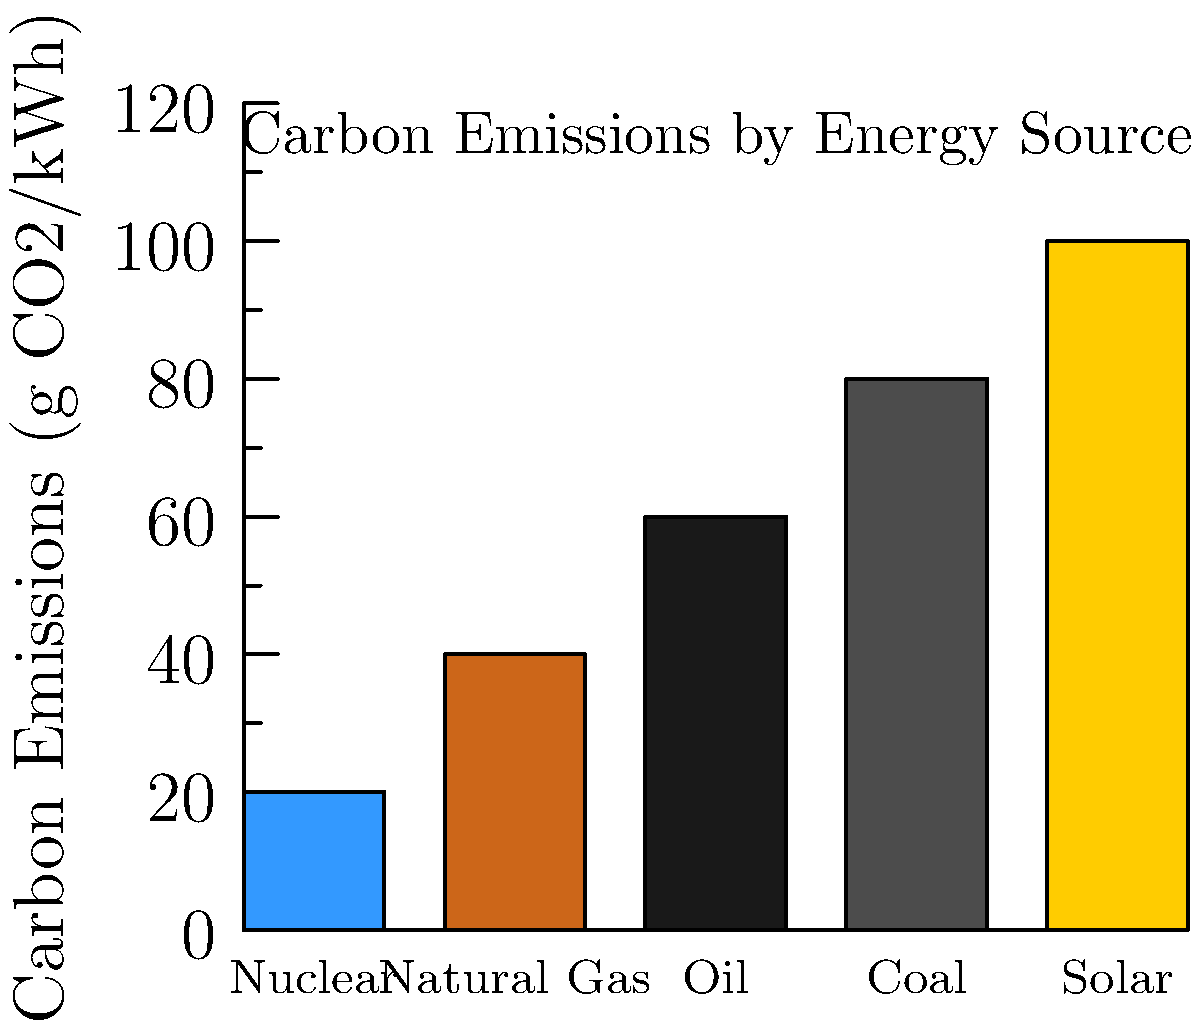Based on the bar chart showing carbon emissions for different energy sources, which fossil fuel source has the lowest carbon emissions per kWh? How would you use this information to support the continued use of fossil fuels in energy production? To answer this question, let's analyze the bar chart step-by-step:

1. The chart shows carbon emissions in grams of CO2 per kWh for five energy sources.
2. The fossil fuel sources shown are Natural Gas, Oil, and Coal.
3. Comparing these three:
   - Natural Gas: approximately 40 g CO2/kWh
   - Oil: approximately 60 g CO2/kWh
   - Coal: approximately 80 g CO2/kWh

4. Among these fossil fuels, Natural Gas has the lowest carbon emissions.

5. To support the continued use of fossil fuels, we can argue:
   a) Natural Gas, as the cleanest fossil fuel, can serve as a transition fuel towards lower-carbon energy systems.
   b) It has significantly lower emissions than coal and oil, making it a preferable option for reducing overall emissions while maintaining energy security.
   c) Natural Gas can provide reliable baseload power, complementing intermittent renewable sources like solar.
   d) The infrastructure for natural gas already exists, making it a cost-effective option for immediate emissions reduction.
   e) Technological improvements in natural gas extraction and utilization can further reduce its carbon footprint.
Answer: Natural Gas; it's the cleanest fossil fuel, providing reliable power while serving as a transition fuel towards lower-carbon energy systems. 